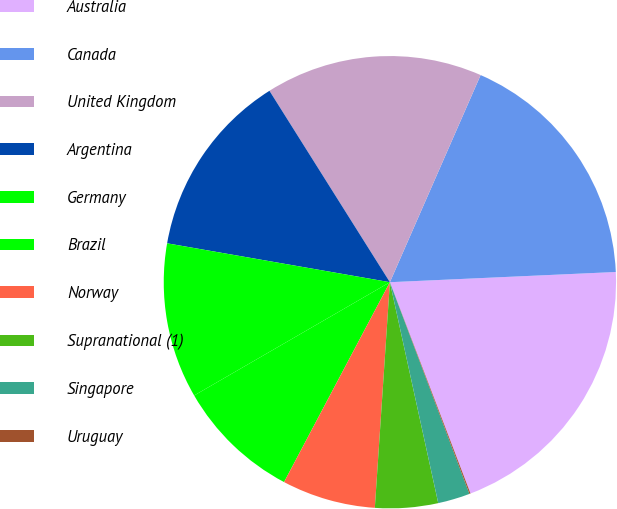Convert chart. <chart><loc_0><loc_0><loc_500><loc_500><pie_chart><fcel>Australia<fcel>Canada<fcel>United Kingdom<fcel>Argentina<fcel>Germany<fcel>Brazil<fcel>Norway<fcel>Supranational (1)<fcel>Singapore<fcel>Uruguay<nl><fcel>19.92%<fcel>17.71%<fcel>15.51%<fcel>13.31%<fcel>11.1%<fcel>8.9%<fcel>6.69%<fcel>4.49%<fcel>2.29%<fcel>0.08%<nl></chart> 